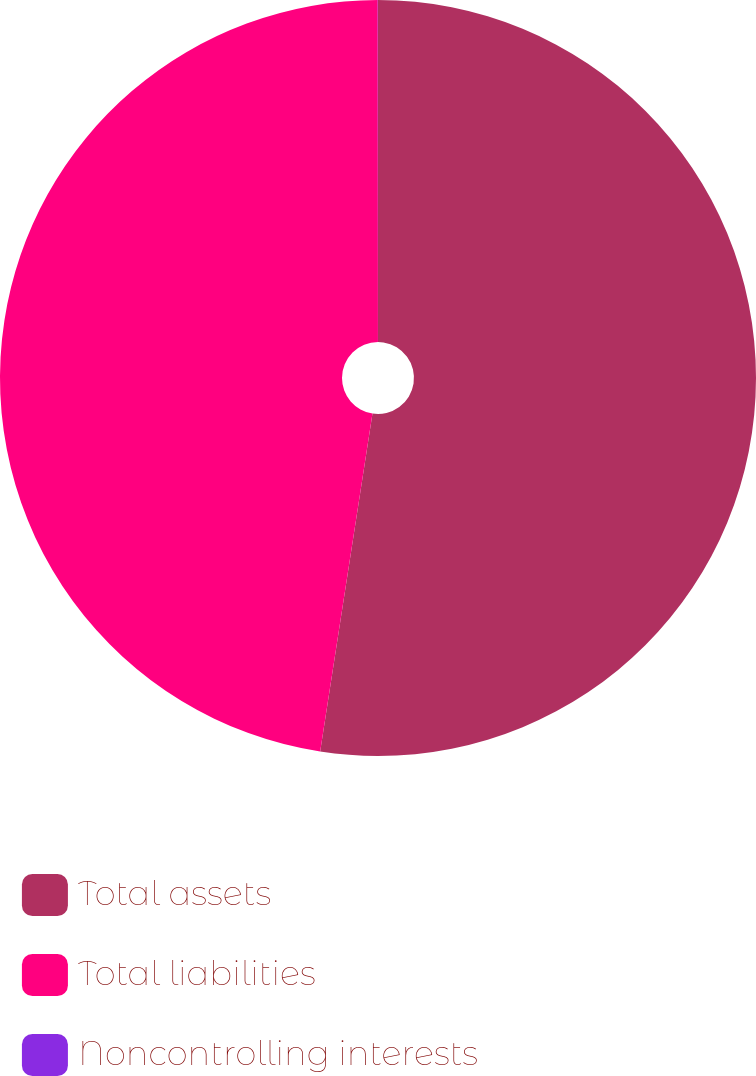<chart> <loc_0><loc_0><loc_500><loc_500><pie_chart><fcel>Total assets<fcel>Total liabilities<fcel>Noncontrolling interests<nl><fcel>52.45%<fcel>47.55%<fcel>0.01%<nl></chart> 